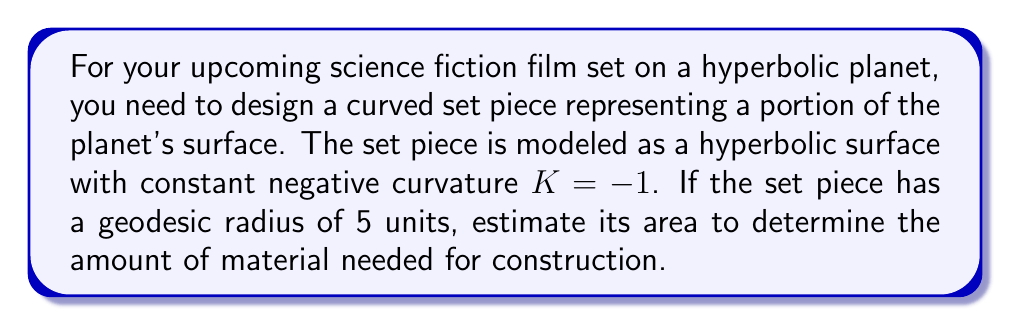Show me your answer to this math problem. To estimate the area of this hyperbolic surface, we'll follow these steps:

1) In hyperbolic geometry, the area of a circle with geodesic radius $r$ is given by the formula:

   $$A = 4\pi \sinh^2(\frac{r}{2})$$

   where $\sinh$ is the hyperbolic sine function.

2) We're given that the radius $r = 5$ and the curvature $K = -1$. The formula above assumes $K = -1$, so we can use it directly.

3) Let's substitute $r = 5$ into the formula:

   $$A = 4\pi \sinh^2(\frac{5}{2})$$

4) Calculate $\frac{5}{2} = 2.5$

5) Now we need to calculate $\sinh(2.5)$. The hyperbolic sine function is defined as:

   $$\sinh(x) = \frac{e^x - e^{-x}}{2}$$

6) Calculating $\sinh(2.5)$:
   
   $$\sinh(2.5) = \frac{e^{2.5} - e^{-2.5}}{2} \approx 6.0502$$

7) Now we square this value:

   $$\sinh^2(2.5) \approx 36.6049$$

8) Finally, we multiply by $4\pi$:

   $$A = 4\pi \cdot 36.6049 \approx 459.9627$$

Therefore, the estimated area of the hyperbolic surface is approximately 459.9627 square units.
Answer: $459.9627$ square units 